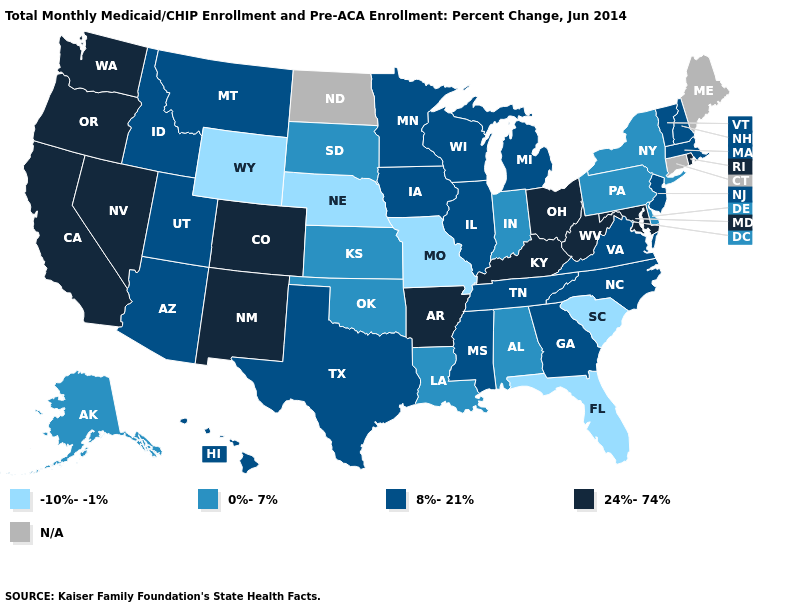What is the value of Ohio?
Write a very short answer. 24%-74%. Name the states that have a value in the range N/A?
Give a very brief answer. Connecticut, Maine, North Dakota. Name the states that have a value in the range 8%-21%?
Be succinct. Arizona, Georgia, Hawaii, Idaho, Illinois, Iowa, Massachusetts, Michigan, Minnesota, Mississippi, Montana, New Hampshire, New Jersey, North Carolina, Tennessee, Texas, Utah, Vermont, Virginia, Wisconsin. What is the highest value in the MidWest ?
Keep it brief. 24%-74%. Which states have the highest value in the USA?
Quick response, please. Arkansas, California, Colorado, Kentucky, Maryland, Nevada, New Mexico, Ohio, Oregon, Rhode Island, Washington, West Virginia. How many symbols are there in the legend?
Concise answer only. 5. What is the value of Massachusetts?
Keep it brief. 8%-21%. Name the states that have a value in the range 8%-21%?
Concise answer only. Arizona, Georgia, Hawaii, Idaho, Illinois, Iowa, Massachusetts, Michigan, Minnesota, Mississippi, Montana, New Hampshire, New Jersey, North Carolina, Tennessee, Texas, Utah, Vermont, Virginia, Wisconsin. What is the value of Pennsylvania?
Write a very short answer. 0%-7%. Name the states that have a value in the range -10%--1%?
Answer briefly. Florida, Missouri, Nebraska, South Carolina, Wyoming. Name the states that have a value in the range 8%-21%?
Concise answer only. Arizona, Georgia, Hawaii, Idaho, Illinois, Iowa, Massachusetts, Michigan, Minnesota, Mississippi, Montana, New Hampshire, New Jersey, North Carolina, Tennessee, Texas, Utah, Vermont, Virginia, Wisconsin. 